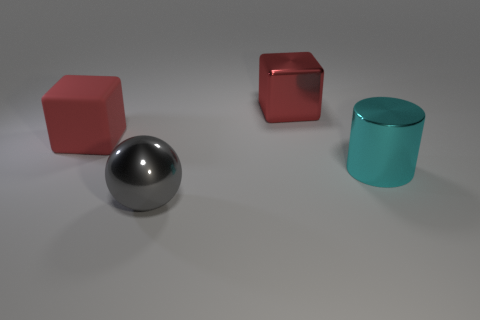How many large shiny balls are there?
Offer a very short reply. 1. There is a cyan shiny object; what shape is it?
Give a very brief answer. Cylinder. What number of metal cubes have the same size as the cyan cylinder?
Provide a succinct answer. 1. Is the shape of the large red matte thing the same as the red metal object?
Provide a short and direct response. Yes. The metallic thing that is behind the red rubber thing in front of the red metal thing is what color?
Offer a very short reply. Red. There is a thing that is to the left of the big cyan object and right of the gray metallic ball; what is its size?
Provide a short and direct response. Large. Is there any other thing of the same color as the large rubber object?
Your answer should be compact. Yes. The cyan object that is the same material as the large gray ball is what shape?
Your answer should be compact. Cylinder. There is a red metallic object; does it have the same shape as the big thing to the left of the gray metallic sphere?
Provide a succinct answer. Yes. The big object left of the metal thing in front of the cyan metal cylinder is made of what material?
Make the answer very short. Rubber. 